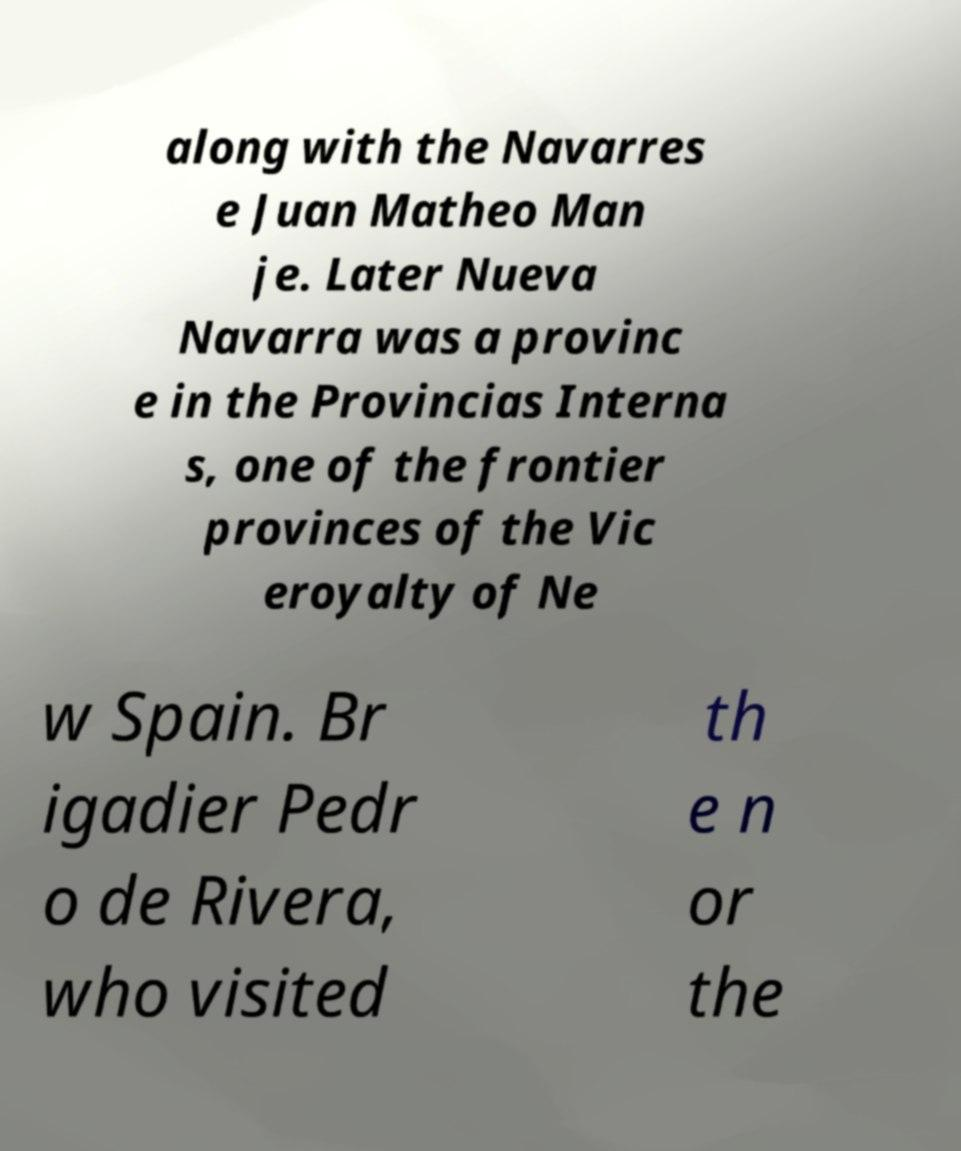I need the written content from this picture converted into text. Can you do that? along with the Navarres e Juan Matheo Man je. Later Nueva Navarra was a provinc e in the Provincias Interna s, one of the frontier provinces of the Vic eroyalty of Ne w Spain. Br igadier Pedr o de Rivera, who visited th e n or the 